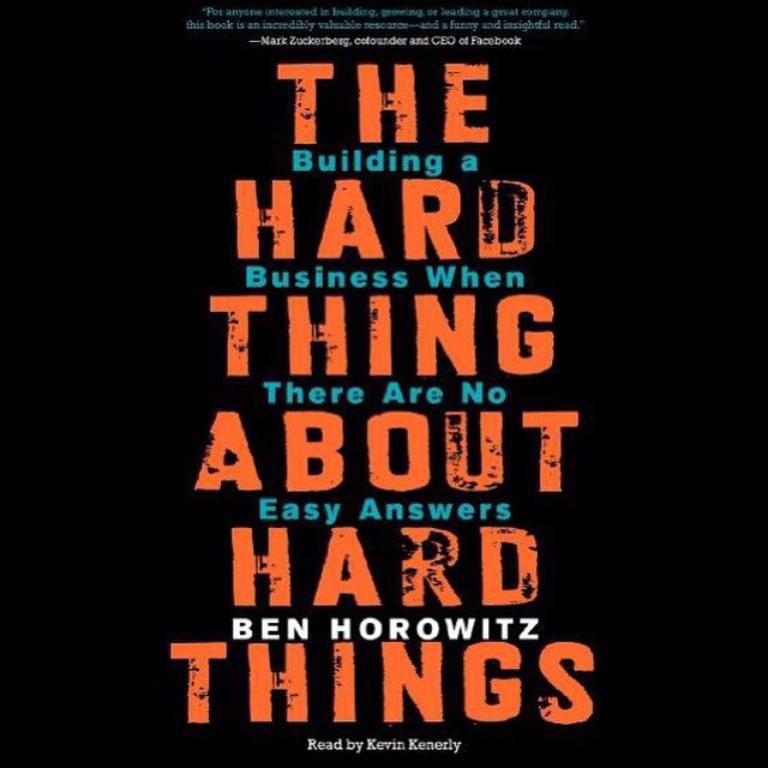<image>
Provide a brief description of the given image. The cover for an audio book called The Hard Thing about Hard Things. 